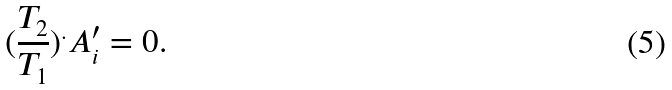Convert formula to latex. <formula><loc_0><loc_0><loc_500><loc_500>( \frac { T _ { 2 } } { T _ { 1 } } ) ^ { . } A ^ { \prime } _ { i } = 0 .</formula> 